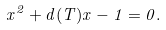<formula> <loc_0><loc_0><loc_500><loc_500>x ^ { 2 } + d ( T ) x - 1 = 0 .</formula> 